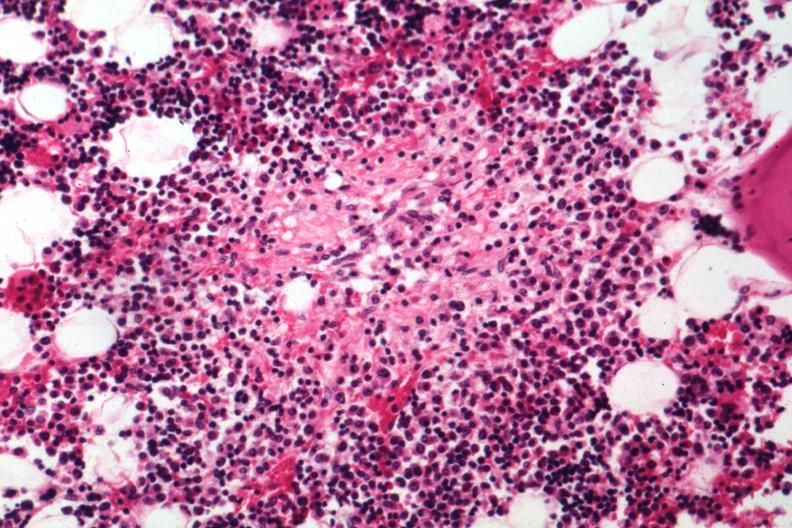what is present?
Answer the question using a single word or phrase. Hematologic 